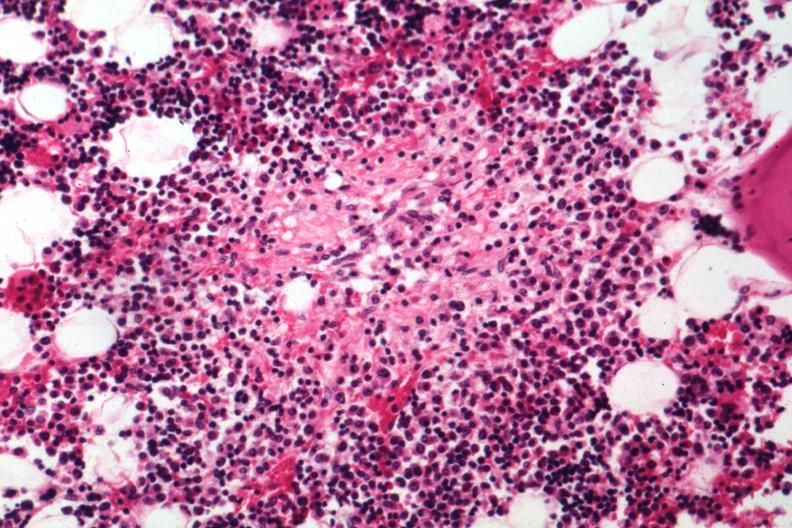what is present?
Answer the question using a single word or phrase. Hematologic 